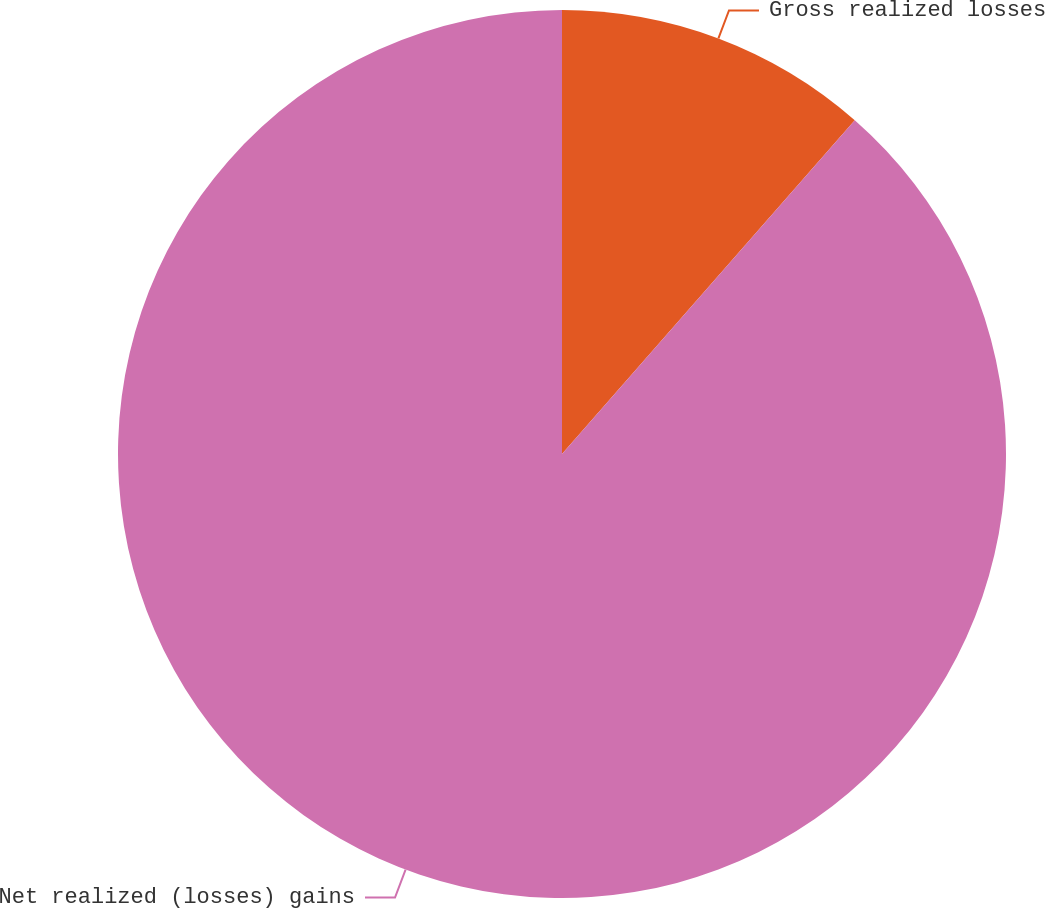Convert chart. <chart><loc_0><loc_0><loc_500><loc_500><pie_chart><fcel>Gross realized losses<fcel>Net realized (losses) gains<nl><fcel>11.46%<fcel>88.54%<nl></chart> 